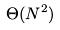Convert formula to latex. <formula><loc_0><loc_0><loc_500><loc_500>\Theta ( N ^ { 2 } )</formula> 